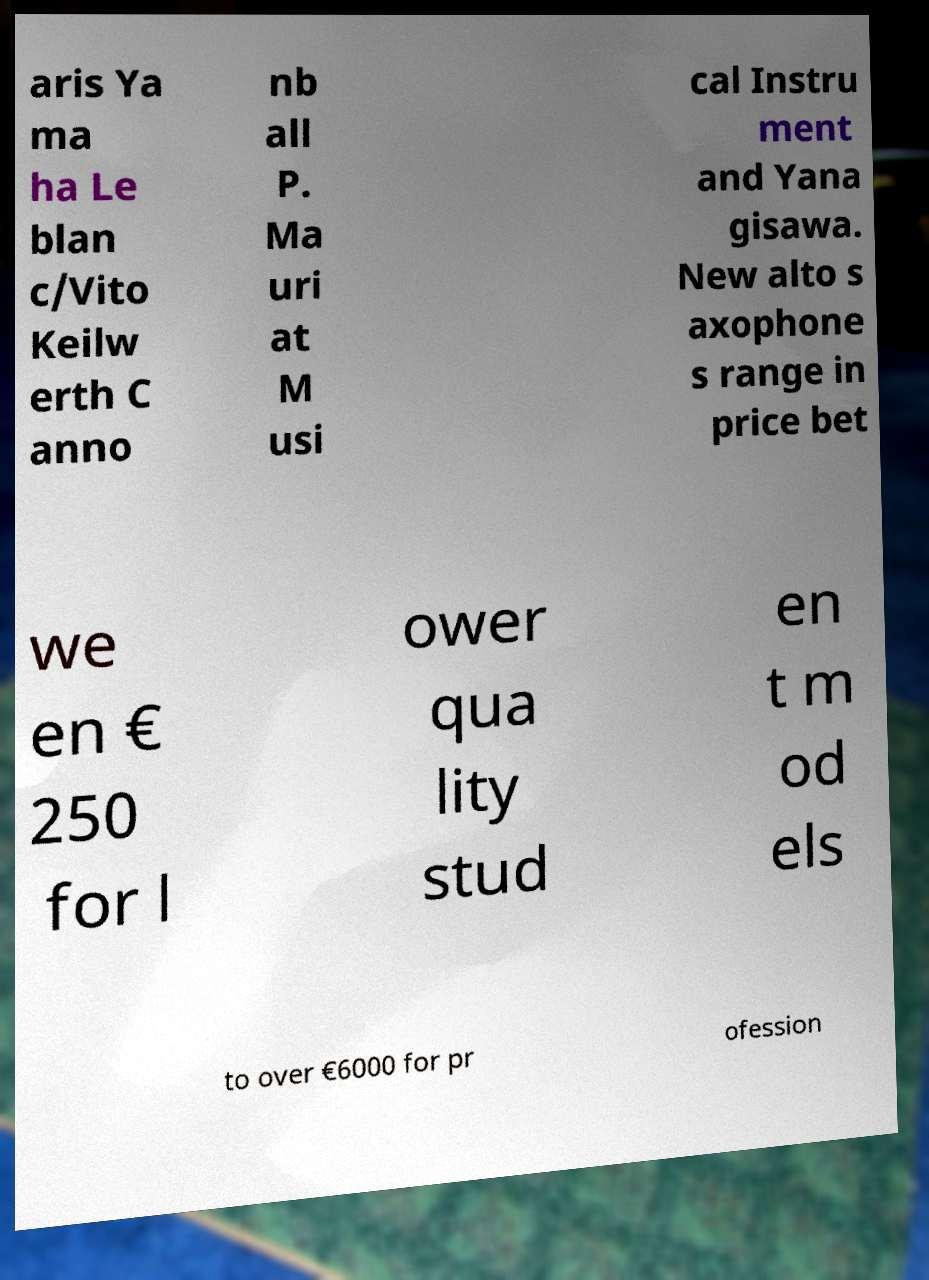What messages or text are displayed in this image? I need them in a readable, typed format. aris Ya ma ha Le blan c/Vito Keilw erth C anno nb all P. Ma uri at M usi cal Instru ment and Yana gisawa. New alto s axophone s range in price bet we en € 250 for l ower qua lity stud en t m od els to over €6000 for pr ofession 